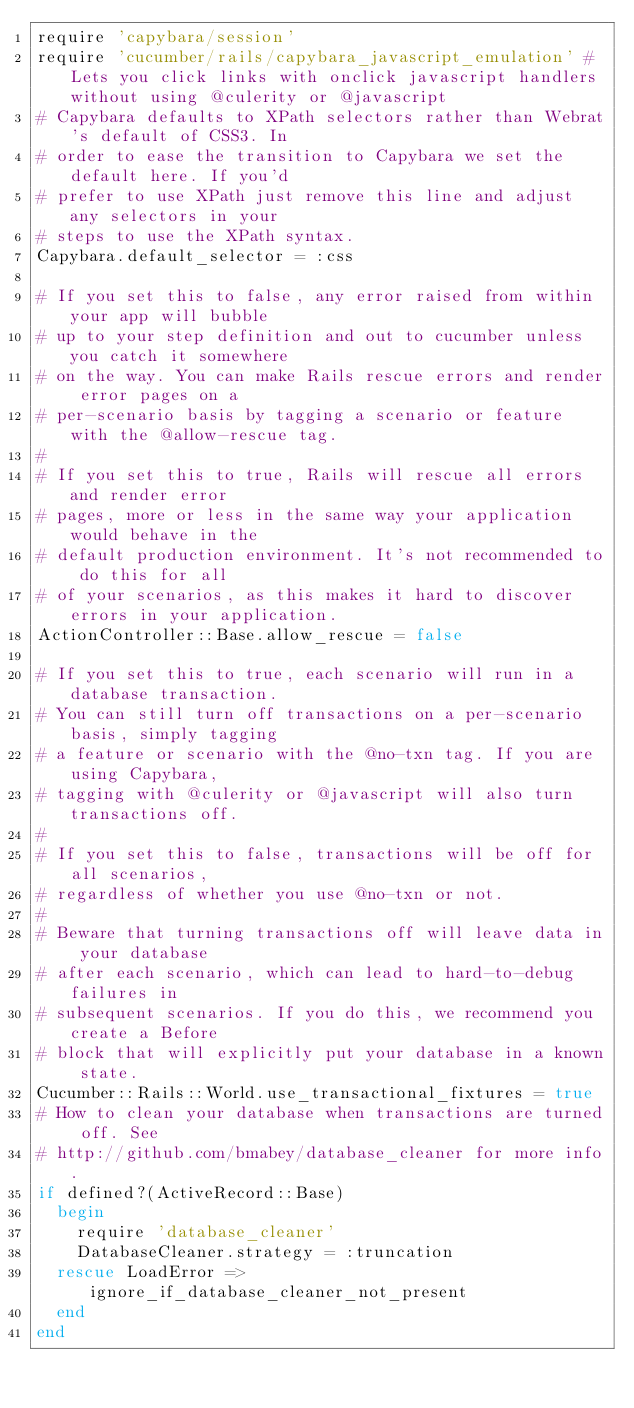Convert code to text. <code><loc_0><loc_0><loc_500><loc_500><_Ruby_>require 'capybara/session'
require 'cucumber/rails/capybara_javascript_emulation' # Lets you click links with onclick javascript handlers without using @culerity or @javascript
# Capybara defaults to XPath selectors rather than Webrat's default of CSS3. In
# order to ease the transition to Capybara we set the default here. If you'd
# prefer to use XPath just remove this line and adjust any selectors in your
# steps to use the XPath syntax.
Capybara.default_selector = :css

# If you set this to false, any error raised from within your app will bubble 
# up to your step definition and out to cucumber unless you catch it somewhere
# on the way. You can make Rails rescue errors and render error pages on a
# per-scenario basis by tagging a scenario or feature with the @allow-rescue tag.
#
# If you set this to true, Rails will rescue all errors and render error
# pages, more or less in the same way your application would behave in the
# default production environment. It's not recommended to do this for all
# of your scenarios, as this makes it hard to discover errors in your application.
ActionController::Base.allow_rescue = false

# If you set this to true, each scenario will run in a database transaction.
# You can still turn off transactions on a per-scenario basis, simply tagging 
# a feature or scenario with the @no-txn tag. If you are using Capybara,
# tagging with @culerity or @javascript will also turn transactions off.
#
# If you set this to false, transactions will be off for all scenarios,
# regardless of whether you use @no-txn or not.
#
# Beware that turning transactions off will leave data in your database 
# after each scenario, which can lead to hard-to-debug failures in 
# subsequent scenarios. If you do this, we recommend you create a Before
# block that will explicitly put your database in a known state.
Cucumber::Rails::World.use_transactional_fixtures = true
# How to clean your database when transactions are turned off. See
# http://github.com/bmabey/database_cleaner for more info.
if defined?(ActiveRecord::Base)
  begin
    require 'database_cleaner'
    DatabaseCleaner.strategy = :truncation
  rescue LoadError => ignore_if_database_cleaner_not_present
  end
end
</code> 